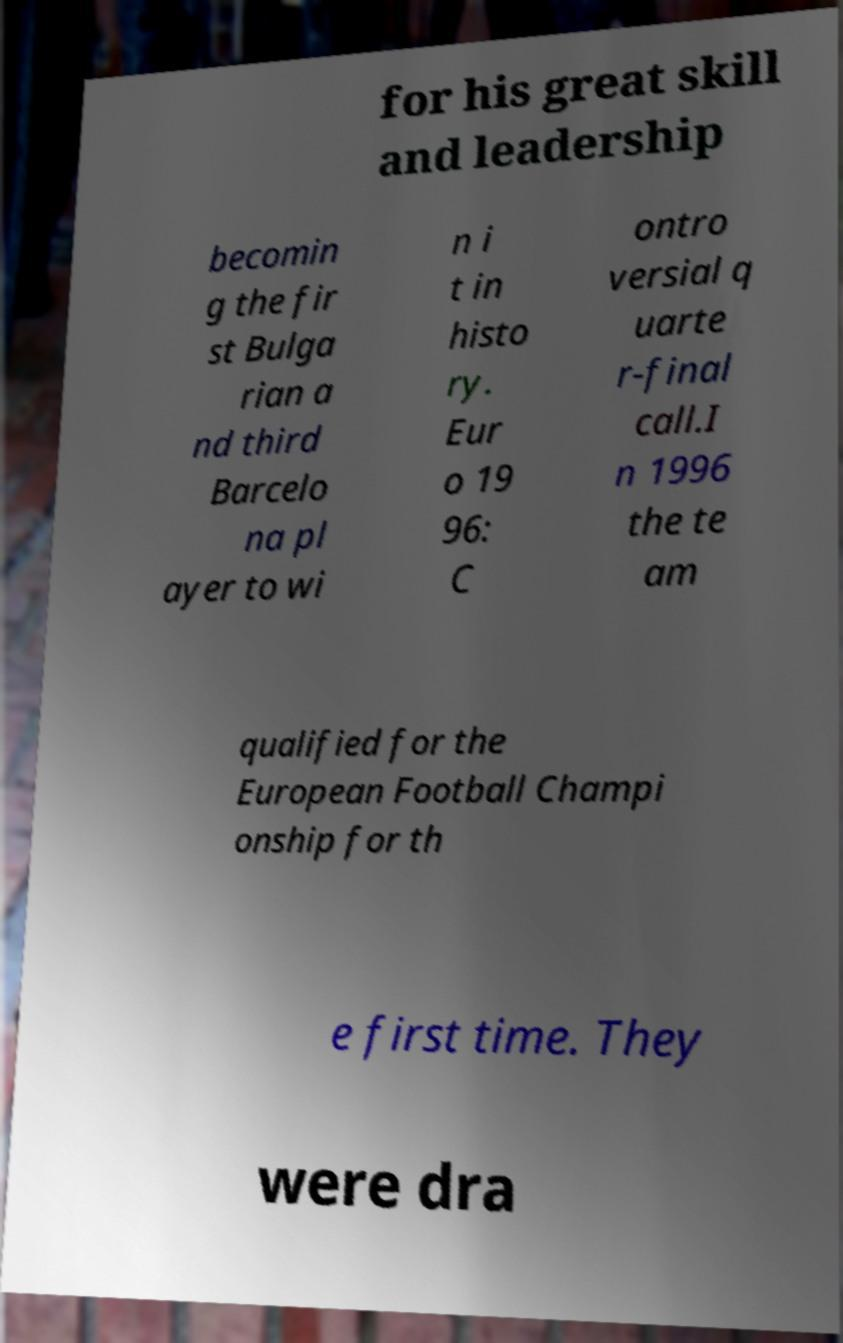Please read and relay the text visible in this image. What does it say? for his great skill and leadership becomin g the fir st Bulga rian a nd third Barcelo na pl ayer to wi n i t in histo ry. Eur o 19 96: C ontro versial q uarte r-final call.I n 1996 the te am qualified for the European Football Champi onship for th e first time. They were dra 